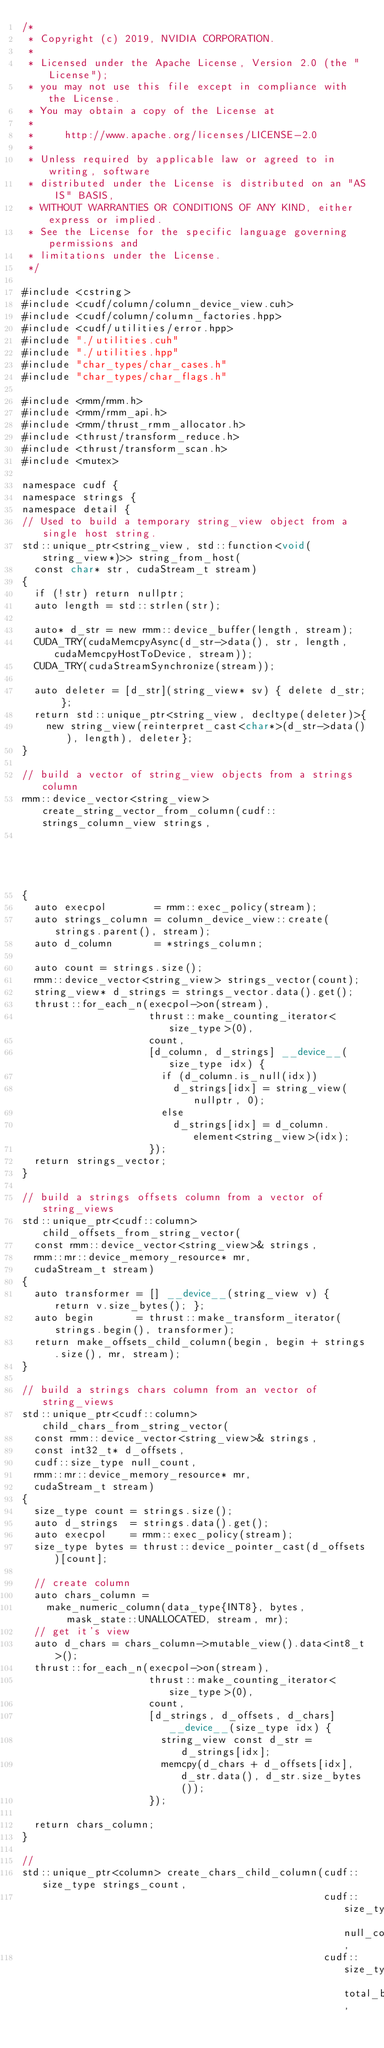<code> <loc_0><loc_0><loc_500><loc_500><_Cuda_>/*
 * Copyright (c) 2019, NVIDIA CORPORATION.
 *
 * Licensed under the Apache License, Version 2.0 (the "License");
 * you may not use this file except in compliance with the License.
 * You may obtain a copy of the License at
 *
 *     http://www.apache.org/licenses/LICENSE-2.0
 *
 * Unless required by applicable law or agreed to in writing, software
 * distributed under the License is distributed on an "AS IS" BASIS,
 * WITHOUT WARRANTIES OR CONDITIONS OF ANY KIND, either express or implied.
 * See the License for the specific language governing permissions and
 * limitations under the License.
 */

#include <cstring>
#include <cudf/column/column_device_view.cuh>
#include <cudf/column/column_factories.hpp>
#include <cudf/utilities/error.hpp>
#include "./utilities.cuh"
#include "./utilities.hpp"
#include "char_types/char_cases.h"
#include "char_types/char_flags.h"

#include <rmm/rmm.h>
#include <rmm/rmm_api.h>
#include <rmm/thrust_rmm_allocator.h>
#include <thrust/transform_reduce.h>
#include <thrust/transform_scan.h>
#include <mutex>

namespace cudf {
namespace strings {
namespace detail {
// Used to build a temporary string_view object from a single host string.
std::unique_ptr<string_view, std::function<void(string_view*)>> string_from_host(
  const char* str, cudaStream_t stream)
{
  if (!str) return nullptr;
  auto length = std::strlen(str);

  auto* d_str = new rmm::device_buffer(length, stream);
  CUDA_TRY(cudaMemcpyAsync(d_str->data(), str, length, cudaMemcpyHostToDevice, stream));
  CUDA_TRY(cudaStreamSynchronize(stream));

  auto deleter = [d_str](string_view* sv) { delete d_str; };
  return std::unique_ptr<string_view, decltype(deleter)>{
    new string_view(reinterpret_cast<char*>(d_str->data()), length), deleter};
}

// build a vector of string_view objects from a strings column
rmm::device_vector<string_view> create_string_vector_from_column(cudf::strings_column_view strings,
                                                                 cudaStream_t stream)
{
  auto execpol        = rmm::exec_policy(stream);
  auto strings_column = column_device_view::create(strings.parent(), stream);
  auto d_column       = *strings_column;

  auto count = strings.size();
  rmm::device_vector<string_view> strings_vector(count);
  string_view* d_strings = strings_vector.data().get();
  thrust::for_each_n(execpol->on(stream),
                     thrust::make_counting_iterator<size_type>(0),
                     count,
                     [d_column, d_strings] __device__(size_type idx) {
                       if (d_column.is_null(idx))
                         d_strings[idx] = string_view(nullptr, 0);
                       else
                         d_strings[idx] = d_column.element<string_view>(idx);
                     });
  return strings_vector;
}

// build a strings offsets column from a vector of string_views
std::unique_ptr<cudf::column> child_offsets_from_string_vector(
  const rmm::device_vector<string_view>& strings,
  rmm::mr::device_memory_resource* mr,
  cudaStream_t stream)
{
  auto transformer = [] __device__(string_view v) { return v.size_bytes(); };
  auto begin       = thrust::make_transform_iterator(strings.begin(), transformer);
  return make_offsets_child_column(begin, begin + strings.size(), mr, stream);
}

// build a strings chars column from an vector of string_views
std::unique_ptr<cudf::column> child_chars_from_string_vector(
  const rmm::device_vector<string_view>& strings,
  const int32_t* d_offsets,
  cudf::size_type null_count,
  rmm::mr::device_memory_resource* mr,
  cudaStream_t stream)
{
  size_type count = strings.size();
  auto d_strings  = strings.data().get();
  auto execpol    = rmm::exec_policy(stream);
  size_type bytes = thrust::device_pointer_cast(d_offsets)[count];

  // create column
  auto chars_column =
    make_numeric_column(data_type{INT8}, bytes, mask_state::UNALLOCATED, stream, mr);
  // get it's view
  auto d_chars = chars_column->mutable_view().data<int8_t>();
  thrust::for_each_n(execpol->on(stream),
                     thrust::make_counting_iterator<size_type>(0),
                     count,
                     [d_strings, d_offsets, d_chars] __device__(size_type idx) {
                       string_view const d_str = d_strings[idx];
                       memcpy(d_chars + d_offsets[idx], d_str.data(), d_str.size_bytes());
                     });

  return chars_column;
}

//
std::unique_ptr<column> create_chars_child_column(cudf::size_type strings_count,
                                                  cudf::size_type null_count,
                                                  cudf::size_type total_bytes,</code> 